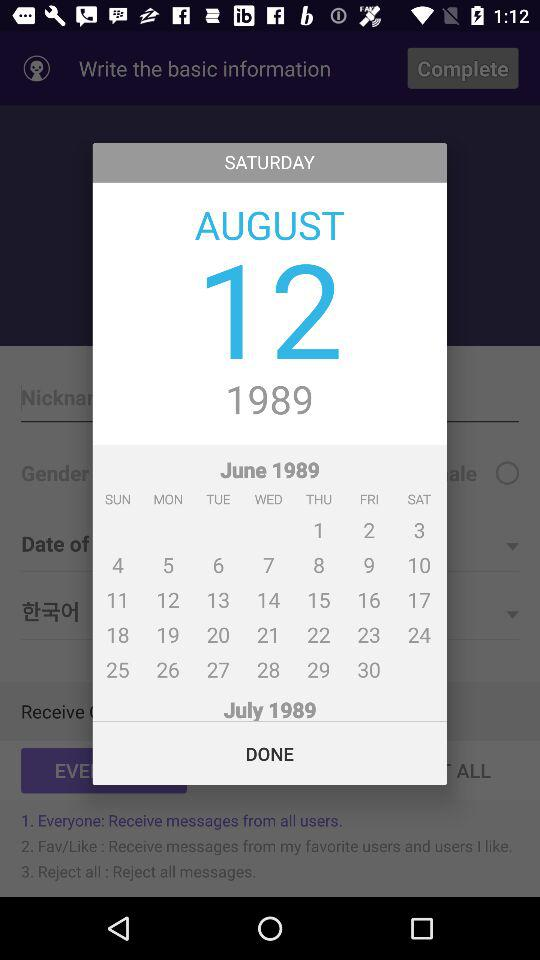What is the day on the 30th of August? The day is Friday. 